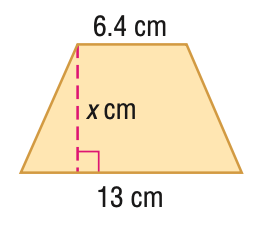Answer the mathemtical geometry problem and directly provide the correct option letter.
Question: Find x. A = 78 cm^2.
Choices: A: 6 B: 8.0 C: 11.5 D: 12.1 B 